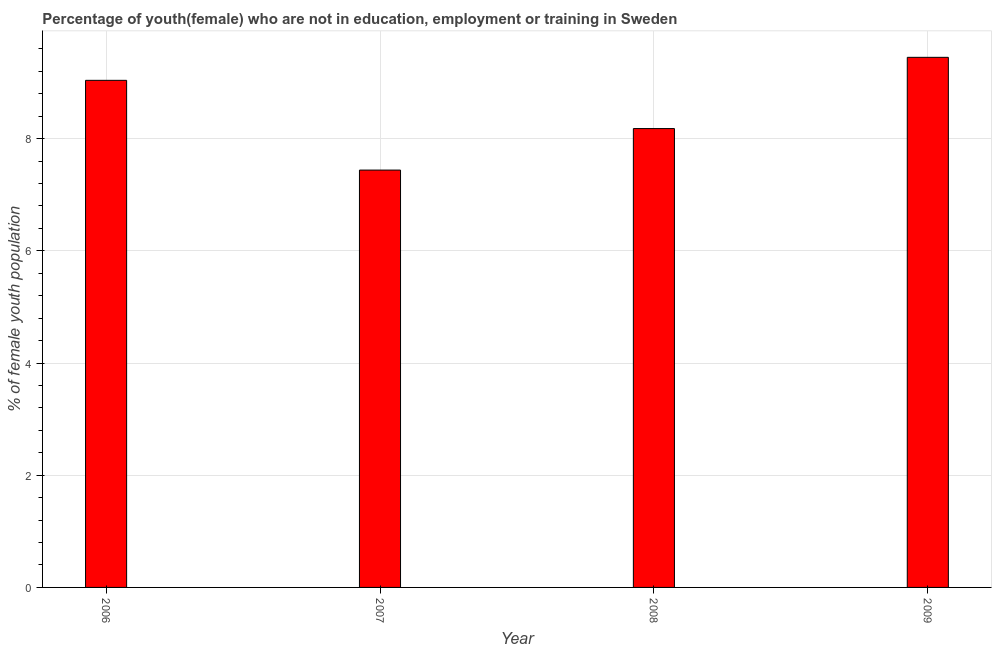Does the graph contain any zero values?
Offer a terse response. No. What is the title of the graph?
Provide a short and direct response. Percentage of youth(female) who are not in education, employment or training in Sweden. What is the label or title of the Y-axis?
Provide a succinct answer. % of female youth population. What is the unemployed female youth population in 2006?
Offer a very short reply. 9.04. Across all years, what is the maximum unemployed female youth population?
Your response must be concise. 9.45. Across all years, what is the minimum unemployed female youth population?
Offer a very short reply. 7.44. What is the sum of the unemployed female youth population?
Provide a succinct answer. 34.11. What is the average unemployed female youth population per year?
Your response must be concise. 8.53. What is the median unemployed female youth population?
Make the answer very short. 8.61. In how many years, is the unemployed female youth population greater than 8.8 %?
Make the answer very short. 2. What is the ratio of the unemployed female youth population in 2008 to that in 2009?
Your response must be concise. 0.87. Is the difference between the unemployed female youth population in 2007 and 2009 greater than the difference between any two years?
Provide a succinct answer. Yes. What is the difference between the highest and the second highest unemployed female youth population?
Provide a short and direct response. 0.41. Is the sum of the unemployed female youth population in 2007 and 2009 greater than the maximum unemployed female youth population across all years?
Give a very brief answer. Yes. What is the difference between the highest and the lowest unemployed female youth population?
Your response must be concise. 2.01. In how many years, is the unemployed female youth population greater than the average unemployed female youth population taken over all years?
Provide a succinct answer. 2. How many years are there in the graph?
Make the answer very short. 4. What is the difference between two consecutive major ticks on the Y-axis?
Make the answer very short. 2. Are the values on the major ticks of Y-axis written in scientific E-notation?
Offer a very short reply. No. What is the % of female youth population in 2006?
Provide a short and direct response. 9.04. What is the % of female youth population of 2007?
Your response must be concise. 7.44. What is the % of female youth population of 2008?
Offer a very short reply. 8.18. What is the % of female youth population of 2009?
Provide a succinct answer. 9.45. What is the difference between the % of female youth population in 2006 and 2008?
Keep it short and to the point. 0.86. What is the difference between the % of female youth population in 2006 and 2009?
Your response must be concise. -0.41. What is the difference between the % of female youth population in 2007 and 2008?
Keep it short and to the point. -0.74. What is the difference between the % of female youth population in 2007 and 2009?
Your answer should be compact. -2.01. What is the difference between the % of female youth population in 2008 and 2009?
Keep it short and to the point. -1.27. What is the ratio of the % of female youth population in 2006 to that in 2007?
Your answer should be very brief. 1.22. What is the ratio of the % of female youth population in 2006 to that in 2008?
Your answer should be compact. 1.1. What is the ratio of the % of female youth population in 2007 to that in 2008?
Make the answer very short. 0.91. What is the ratio of the % of female youth population in 2007 to that in 2009?
Offer a very short reply. 0.79. What is the ratio of the % of female youth population in 2008 to that in 2009?
Give a very brief answer. 0.87. 